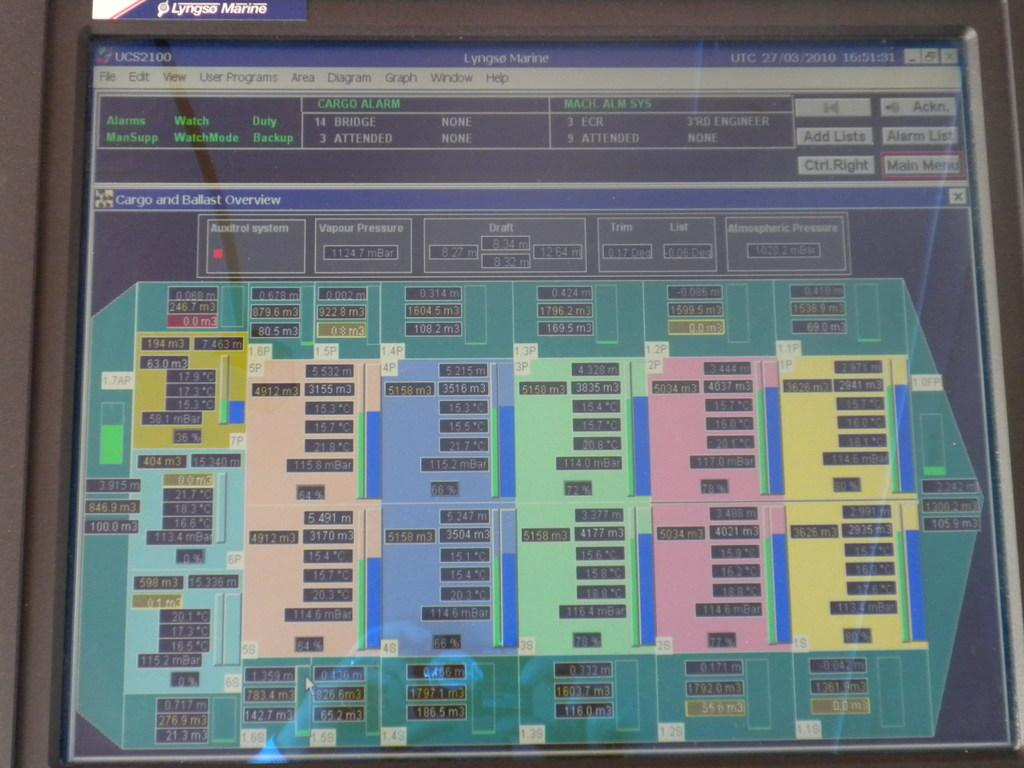<image>
Present a compact description of the photo's key features. A display in Lyngso Marine, an apparent map of the inside of a ship. 